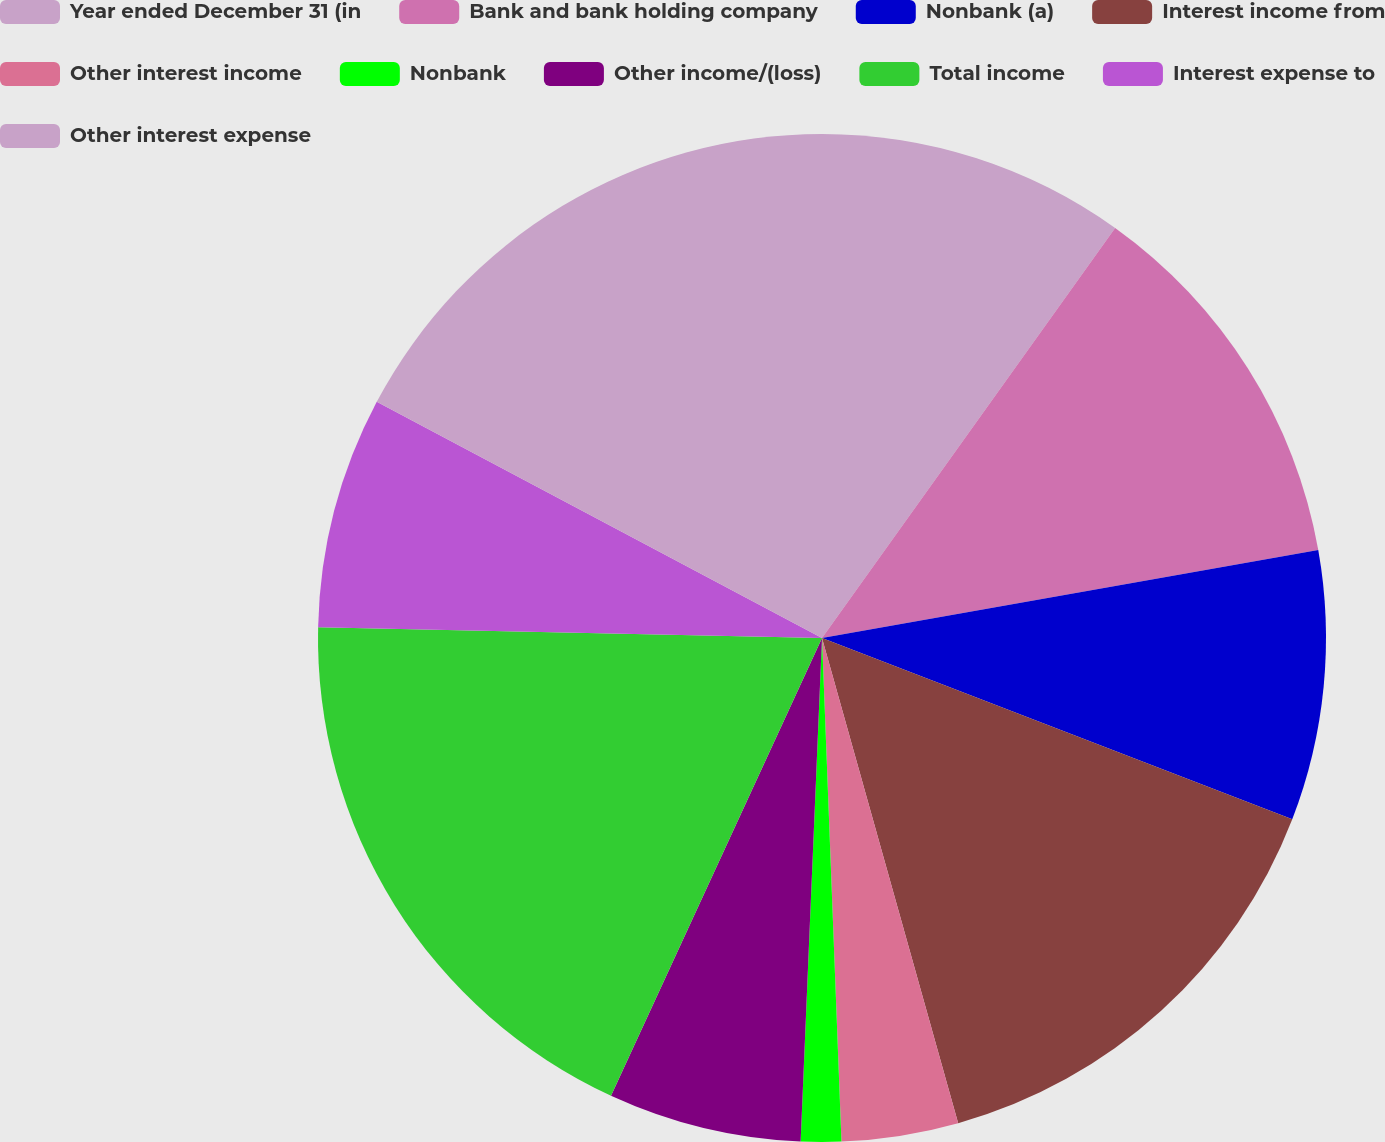Convert chart. <chart><loc_0><loc_0><loc_500><loc_500><pie_chart><fcel>Year ended December 31 (in<fcel>Bank and bank holding company<fcel>Nonbank (a)<fcel>Interest income from<fcel>Other interest income<fcel>Nonbank<fcel>Other income/(loss)<fcel>Total income<fcel>Interest expense to<fcel>Other interest expense<nl><fcel>9.88%<fcel>12.33%<fcel>8.65%<fcel>14.79%<fcel>3.74%<fcel>1.29%<fcel>6.2%<fcel>18.47%<fcel>7.42%<fcel>17.24%<nl></chart> 